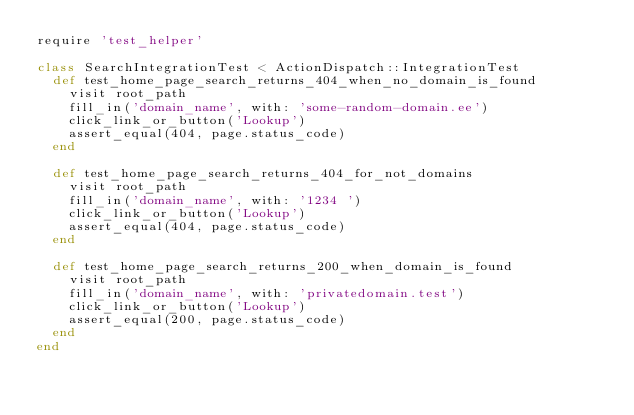Convert code to text. <code><loc_0><loc_0><loc_500><loc_500><_Ruby_>require 'test_helper'

class SearchIntegrationTest < ActionDispatch::IntegrationTest
  def test_home_page_search_returns_404_when_no_domain_is_found
    visit root_path
    fill_in('domain_name', with: 'some-random-domain.ee')
    click_link_or_button('Lookup')
    assert_equal(404, page.status_code)
  end

  def test_home_page_search_returns_404_for_not_domains
    visit root_path
    fill_in('domain_name', with: '1234 ')
    click_link_or_button('Lookup')
    assert_equal(404, page.status_code)
  end

  def test_home_page_search_returns_200_when_domain_is_found
    visit root_path
    fill_in('domain_name', with: 'privatedomain.test')
    click_link_or_button('Lookup')
    assert_equal(200, page.status_code)
  end
end
</code> 